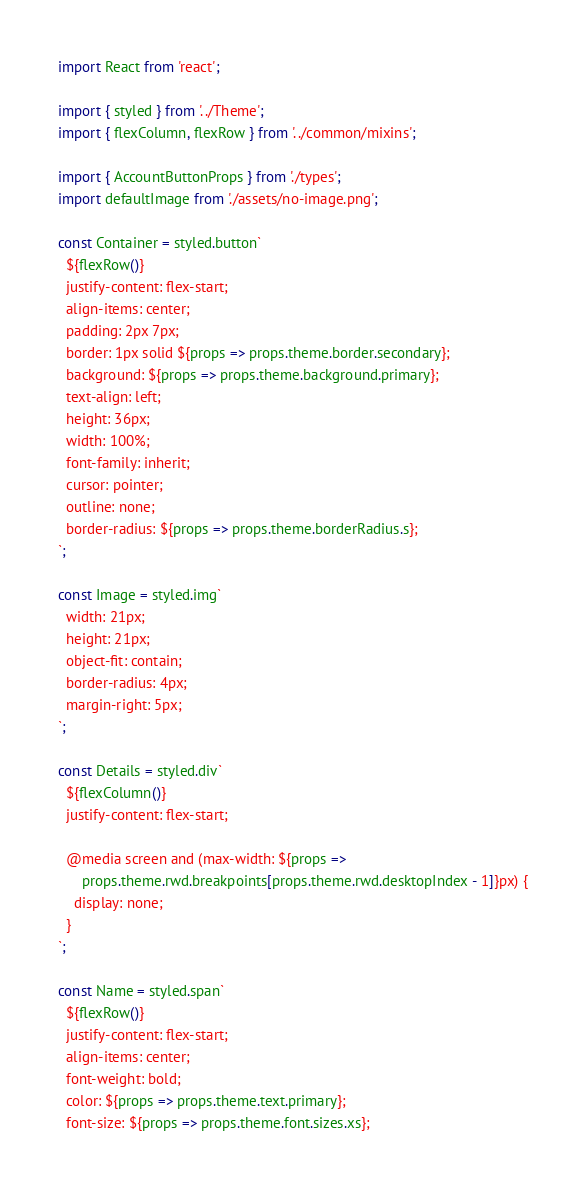<code> <loc_0><loc_0><loc_500><loc_500><_TypeScript_>import React from 'react';

import { styled } from '../Theme';
import { flexColumn, flexRow } from '../common/mixins';

import { AccountButtonProps } from './types';
import defaultImage from './assets/no-image.png';

const Container = styled.button`
  ${flexRow()}
  justify-content: flex-start;
  align-items: center;
  padding: 2px 7px;
  border: 1px solid ${props => props.theme.border.secondary};
  background: ${props => props.theme.background.primary};
  text-align: left;
  height: 36px;
  width: 100%;
  font-family: inherit;
  cursor: pointer;
  outline: none;
  border-radius: ${props => props.theme.borderRadius.s};
`;

const Image = styled.img`
  width: 21px;
  height: 21px;
  object-fit: contain;
  border-radius: 4px;
  margin-right: 5px;
`;

const Details = styled.div`
  ${flexColumn()}
  justify-content: flex-start;

  @media screen and (max-width: ${props =>
      props.theme.rwd.breakpoints[props.theme.rwd.desktopIndex - 1]}px) {
    display: none;
  }
`;

const Name = styled.span`
  ${flexRow()}
  justify-content: flex-start;
  align-items: center;
  font-weight: bold;
  color: ${props => props.theme.text.primary};
  font-size: ${props => props.theme.font.sizes.xs};</code> 